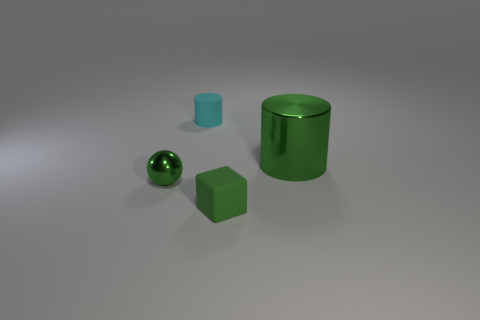Add 1 tiny cyan cylinders. How many objects exist? 5 Subtract all cubes. How many objects are left? 3 Add 2 tiny purple cubes. How many tiny purple cubes exist? 2 Subtract 1 green cylinders. How many objects are left? 3 Subtract all large green metallic cylinders. Subtract all large green cylinders. How many objects are left? 2 Add 3 green shiny balls. How many green shiny balls are left? 4 